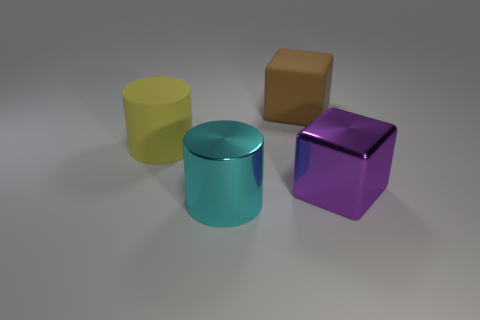There is a large purple block; are there any large shiny cubes right of it?
Keep it short and to the point. No. What shape is the brown matte thing?
Keep it short and to the point. Cube. What shape is the shiny object on the left side of the big cube that is in front of the large cylinder behind the cyan shiny cylinder?
Make the answer very short. Cylinder. What number of other objects are the same shape as the large purple thing?
Ensure brevity in your answer.  1. What material is the big cylinder behind the cyan thing in front of the big purple shiny block made of?
Keep it short and to the point. Rubber. Are there any other things that are the same size as the brown matte object?
Keep it short and to the point. Yes. Is the material of the big yellow cylinder the same as the big cylinder that is to the right of the yellow thing?
Give a very brief answer. No. What is the large thing that is both behind the purple object and right of the large matte cylinder made of?
Give a very brief answer. Rubber. There is a large block that is in front of the rubber thing that is on the right side of the cyan thing; what is its color?
Make the answer very short. Purple. What material is the cube that is behind the yellow thing?
Your answer should be compact. Rubber. 